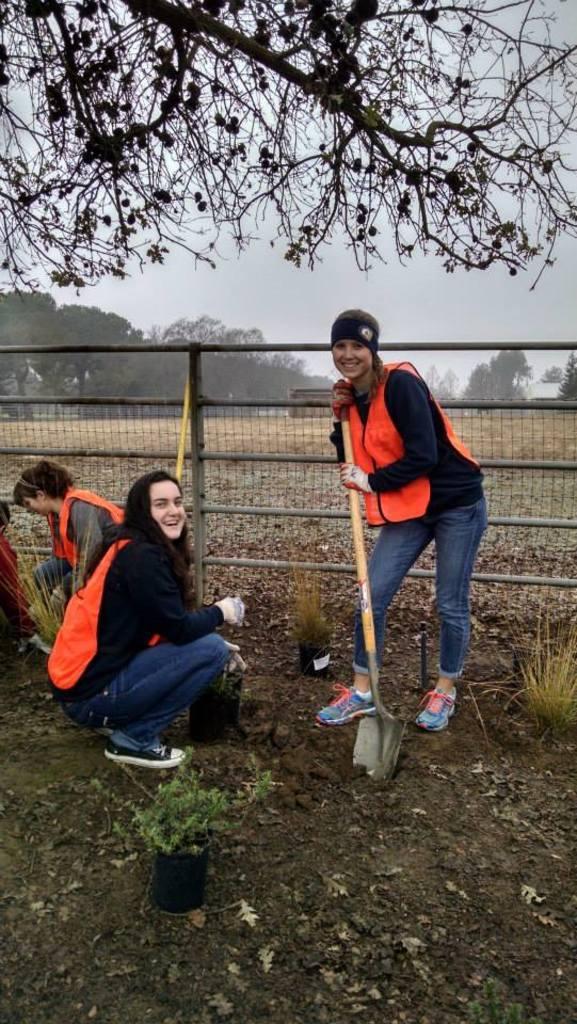How would you summarize this image in a sentence or two? In this image we can see few women. One lady is holding a spade. There are pot with plants. In the back there is a fencing with poles and mesh. At the top there are branches. In the background there are trees and sky. 